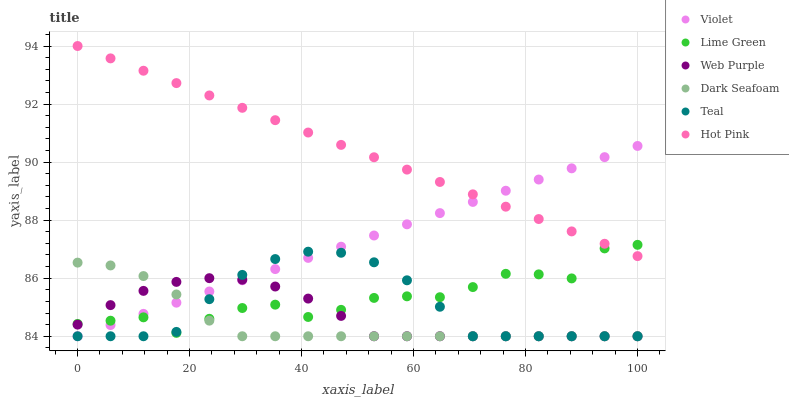Does Dark Seafoam have the minimum area under the curve?
Answer yes or no. Yes. Does Hot Pink have the maximum area under the curve?
Answer yes or no. Yes. Does Web Purple have the minimum area under the curve?
Answer yes or no. No. Does Web Purple have the maximum area under the curve?
Answer yes or no. No. Is Hot Pink the smoothest?
Answer yes or no. Yes. Is Lime Green the roughest?
Answer yes or no. Yes. Is Dark Seafoam the smoothest?
Answer yes or no. No. Is Dark Seafoam the roughest?
Answer yes or no. No. Does Dark Seafoam have the lowest value?
Answer yes or no. Yes. Does Lime Green have the lowest value?
Answer yes or no. No. Does Hot Pink have the highest value?
Answer yes or no. Yes. Does Dark Seafoam have the highest value?
Answer yes or no. No. Is Web Purple less than Hot Pink?
Answer yes or no. Yes. Is Hot Pink greater than Web Purple?
Answer yes or no. Yes. Does Dark Seafoam intersect Teal?
Answer yes or no. Yes. Is Dark Seafoam less than Teal?
Answer yes or no. No. Is Dark Seafoam greater than Teal?
Answer yes or no. No. Does Web Purple intersect Hot Pink?
Answer yes or no. No. 